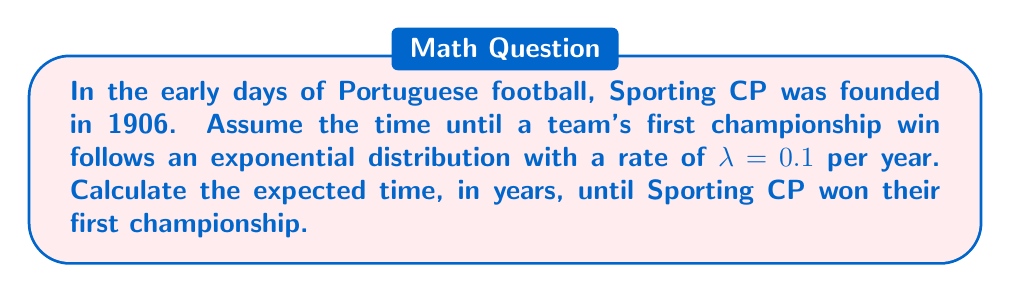Teach me how to tackle this problem. To solve this problem, we'll use survival analysis and the properties of the exponential distribution:

1) For an exponential distribution with rate $\lambda$, the expected value (mean) is given by:

   $$E[X] = \frac{1}{\lambda}$$

2) In this case, $\lambda = 0.1$ per year.

3) Substituting this value into the formula:

   $$E[X] = \frac{1}{0.1}$$

4) Simplifying:

   $$E[X] = 10$$

5) Therefore, the expected time until Sporting CP won their first championship is 10 years.

Note: This is a theoretical calculation based on the given exponential distribution. In reality, Sporting CP won their first official championship in 1941, about 35 years after their founding.
Answer: 10 years 